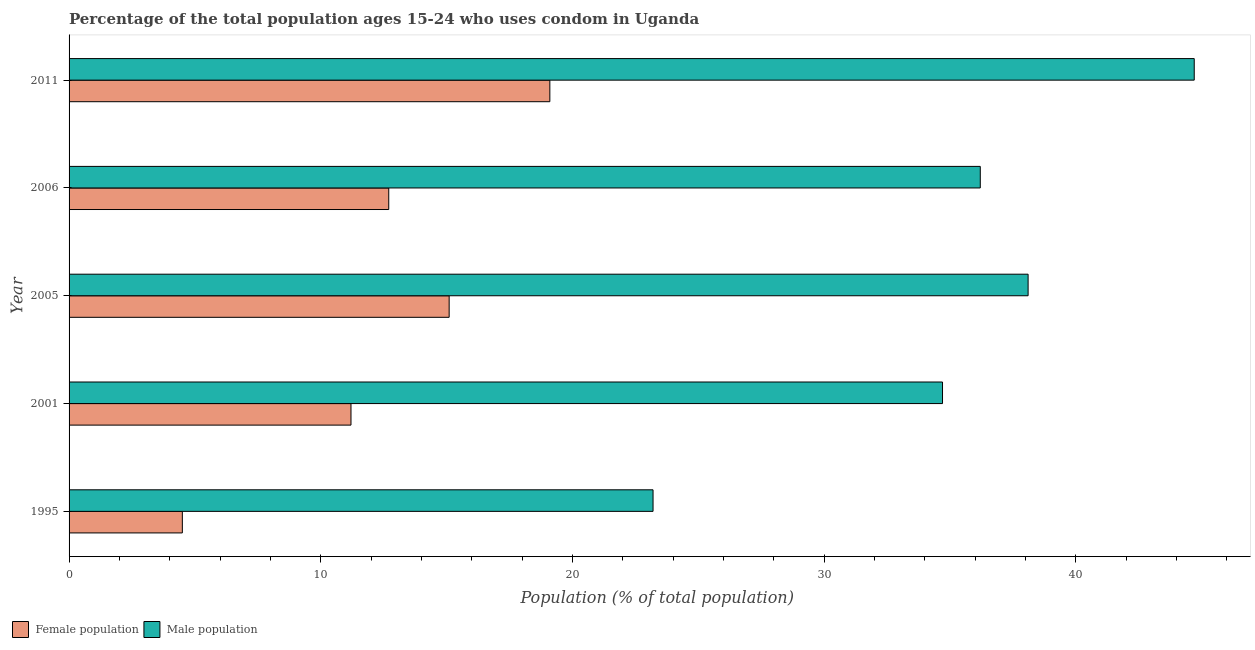How many groups of bars are there?
Keep it short and to the point. 5. Are the number of bars per tick equal to the number of legend labels?
Provide a short and direct response. Yes. What is the male population in 2011?
Offer a terse response. 44.7. Across all years, what is the maximum male population?
Ensure brevity in your answer.  44.7. Across all years, what is the minimum male population?
Offer a very short reply. 23.2. In which year was the male population maximum?
Offer a very short reply. 2011. In which year was the female population minimum?
Give a very brief answer. 1995. What is the total female population in the graph?
Give a very brief answer. 62.6. What is the difference between the female population in 1995 and the male population in 2005?
Your response must be concise. -33.6. What is the average male population per year?
Keep it short and to the point. 35.38. In the year 2001, what is the difference between the female population and male population?
Provide a succinct answer. -23.5. What is the ratio of the male population in 2005 to that in 2006?
Your answer should be very brief. 1.05. Is the female population in 2001 less than that in 2005?
Provide a succinct answer. Yes. Is the difference between the male population in 1995 and 2001 greater than the difference between the female population in 1995 and 2001?
Give a very brief answer. No. What is the difference between the highest and the lowest female population?
Make the answer very short. 14.6. What does the 1st bar from the top in 1995 represents?
Offer a very short reply. Male population. What does the 2nd bar from the bottom in 2001 represents?
Your answer should be very brief. Male population. How many years are there in the graph?
Your answer should be compact. 5. What is the difference between two consecutive major ticks on the X-axis?
Your answer should be very brief. 10. Are the values on the major ticks of X-axis written in scientific E-notation?
Your answer should be very brief. No. How many legend labels are there?
Your response must be concise. 2. How are the legend labels stacked?
Your answer should be compact. Horizontal. What is the title of the graph?
Offer a very short reply. Percentage of the total population ages 15-24 who uses condom in Uganda. What is the label or title of the X-axis?
Your answer should be very brief. Population (% of total population) . What is the label or title of the Y-axis?
Offer a very short reply. Year. What is the Population (% of total population)  of Male population in 1995?
Offer a terse response. 23.2. What is the Population (% of total population)  of Female population in 2001?
Provide a succinct answer. 11.2. What is the Population (% of total population)  of Male population in 2001?
Ensure brevity in your answer.  34.7. What is the Population (% of total population)  in Male population in 2005?
Make the answer very short. 38.1. What is the Population (% of total population)  in Female population in 2006?
Keep it short and to the point. 12.7. What is the Population (% of total population)  of Male population in 2006?
Provide a short and direct response. 36.2. What is the Population (% of total population)  of Male population in 2011?
Your answer should be very brief. 44.7. Across all years, what is the maximum Population (% of total population)  in Male population?
Give a very brief answer. 44.7. Across all years, what is the minimum Population (% of total population)  of Male population?
Keep it short and to the point. 23.2. What is the total Population (% of total population)  in Female population in the graph?
Provide a succinct answer. 62.6. What is the total Population (% of total population)  in Male population in the graph?
Provide a succinct answer. 176.9. What is the difference between the Population (% of total population)  in Female population in 1995 and that in 2001?
Offer a terse response. -6.7. What is the difference between the Population (% of total population)  in Male population in 1995 and that in 2001?
Offer a very short reply. -11.5. What is the difference between the Population (% of total population)  in Female population in 1995 and that in 2005?
Provide a short and direct response. -10.6. What is the difference between the Population (% of total population)  in Male population in 1995 and that in 2005?
Your response must be concise. -14.9. What is the difference between the Population (% of total population)  in Male population in 1995 and that in 2006?
Your answer should be compact. -13. What is the difference between the Population (% of total population)  of Female population in 1995 and that in 2011?
Make the answer very short. -14.6. What is the difference between the Population (% of total population)  in Male population in 1995 and that in 2011?
Ensure brevity in your answer.  -21.5. What is the difference between the Population (% of total population)  of Male population in 2001 and that in 2005?
Give a very brief answer. -3.4. What is the difference between the Population (% of total population)  in Female population in 2001 and that in 2006?
Offer a very short reply. -1.5. What is the difference between the Population (% of total population)  in Male population in 2001 and that in 2011?
Your response must be concise. -10. What is the difference between the Population (% of total population)  of Female population in 2005 and that in 2006?
Your answer should be compact. 2.4. What is the difference between the Population (% of total population)  in Male population in 2005 and that in 2006?
Keep it short and to the point. 1.9. What is the difference between the Population (% of total population)  of Male population in 2005 and that in 2011?
Keep it short and to the point. -6.6. What is the difference between the Population (% of total population)  in Male population in 2006 and that in 2011?
Provide a short and direct response. -8.5. What is the difference between the Population (% of total population)  of Female population in 1995 and the Population (% of total population)  of Male population in 2001?
Provide a short and direct response. -30.2. What is the difference between the Population (% of total population)  of Female population in 1995 and the Population (% of total population)  of Male population in 2005?
Provide a succinct answer. -33.6. What is the difference between the Population (% of total population)  in Female population in 1995 and the Population (% of total population)  in Male population in 2006?
Offer a terse response. -31.7. What is the difference between the Population (% of total population)  in Female population in 1995 and the Population (% of total population)  in Male population in 2011?
Provide a succinct answer. -40.2. What is the difference between the Population (% of total population)  in Female population in 2001 and the Population (% of total population)  in Male population in 2005?
Make the answer very short. -26.9. What is the difference between the Population (% of total population)  of Female population in 2001 and the Population (% of total population)  of Male population in 2006?
Ensure brevity in your answer.  -25. What is the difference between the Population (% of total population)  of Female population in 2001 and the Population (% of total population)  of Male population in 2011?
Ensure brevity in your answer.  -33.5. What is the difference between the Population (% of total population)  in Female population in 2005 and the Population (% of total population)  in Male population in 2006?
Ensure brevity in your answer.  -21.1. What is the difference between the Population (% of total population)  in Female population in 2005 and the Population (% of total population)  in Male population in 2011?
Provide a succinct answer. -29.6. What is the difference between the Population (% of total population)  of Female population in 2006 and the Population (% of total population)  of Male population in 2011?
Offer a very short reply. -32. What is the average Population (% of total population)  in Female population per year?
Keep it short and to the point. 12.52. What is the average Population (% of total population)  of Male population per year?
Offer a very short reply. 35.38. In the year 1995, what is the difference between the Population (% of total population)  in Female population and Population (% of total population)  in Male population?
Provide a succinct answer. -18.7. In the year 2001, what is the difference between the Population (% of total population)  of Female population and Population (% of total population)  of Male population?
Give a very brief answer. -23.5. In the year 2005, what is the difference between the Population (% of total population)  of Female population and Population (% of total population)  of Male population?
Your answer should be compact. -23. In the year 2006, what is the difference between the Population (% of total population)  of Female population and Population (% of total population)  of Male population?
Give a very brief answer. -23.5. In the year 2011, what is the difference between the Population (% of total population)  in Female population and Population (% of total population)  in Male population?
Your answer should be compact. -25.6. What is the ratio of the Population (% of total population)  of Female population in 1995 to that in 2001?
Provide a succinct answer. 0.4. What is the ratio of the Population (% of total population)  of Male population in 1995 to that in 2001?
Your answer should be very brief. 0.67. What is the ratio of the Population (% of total population)  of Female population in 1995 to that in 2005?
Offer a terse response. 0.3. What is the ratio of the Population (% of total population)  in Male population in 1995 to that in 2005?
Provide a succinct answer. 0.61. What is the ratio of the Population (% of total population)  in Female population in 1995 to that in 2006?
Keep it short and to the point. 0.35. What is the ratio of the Population (% of total population)  in Male population in 1995 to that in 2006?
Your response must be concise. 0.64. What is the ratio of the Population (% of total population)  of Female population in 1995 to that in 2011?
Your answer should be compact. 0.24. What is the ratio of the Population (% of total population)  in Male population in 1995 to that in 2011?
Your response must be concise. 0.52. What is the ratio of the Population (% of total population)  of Female population in 2001 to that in 2005?
Provide a short and direct response. 0.74. What is the ratio of the Population (% of total population)  of Male population in 2001 to that in 2005?
Your answer should be compact. 0.91. What is the ratio of the Population (% of total population)  in Female population in 2001 to that in 2006?
Make the answer very short. 0.88. What is the ratio of the Population (% of total population)  of Male population in 2001 to that in 2006?
Your answer should be compact. 0.96. What is the ratio of the Population (% of total population)  of Female population in 2001 to that in 2011?
Provide a short and direct response. 0.59. What is the ratio of the Population (% of total population)  of Male population in 2001 to that in 2011?
Provide a succinct answer. 0.78. What is the ratio of the Population (% of total population)  of Female population in 2005 to that in 2006?
Ensure brevity in your answer.  1.19. What is the ratio of the Population (% of total population)  of Male population in 2005 to that in 2006?
Give a very brief answer. 1.05. What is the ratio of the Population (% of total population)  of Female population in 2005 to that in 2011?
Your response must be concise. 0.79. What is the ratio of the Population (% of total population)  in Male population in 2005 to that in 2011?
Provide a succinct answer. 0.85. What is the ratio of the Population (% of total population)  of Female population in 2006 to that in 2011?
Ensure brevity in your answer.  0.66. What is the ratio of the Population (% of total population)  of Male population in 2006 to that in 2011?
Your response must be concise. 0.81. What is the difference between the highest and the second highest Population (% of total population)  of Male population?
Keep it short and to the point. 6.6. 